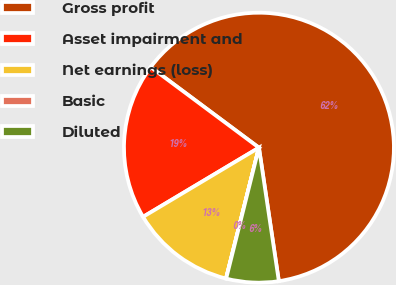Convert chart to OTSL. <chart><loc_0><loc_0><loc_500><loc_500><pie_chart><fcel>Gross profit<fcel>Asset impairment and<fcel>Net earnings (loss)<fcel>Basic<fcel>Diluted<nl><fcel>62.46%<fcel>18.75%<fcel>12.51%<fcel>0.02%<fcel>6.26%<nl></chart> 